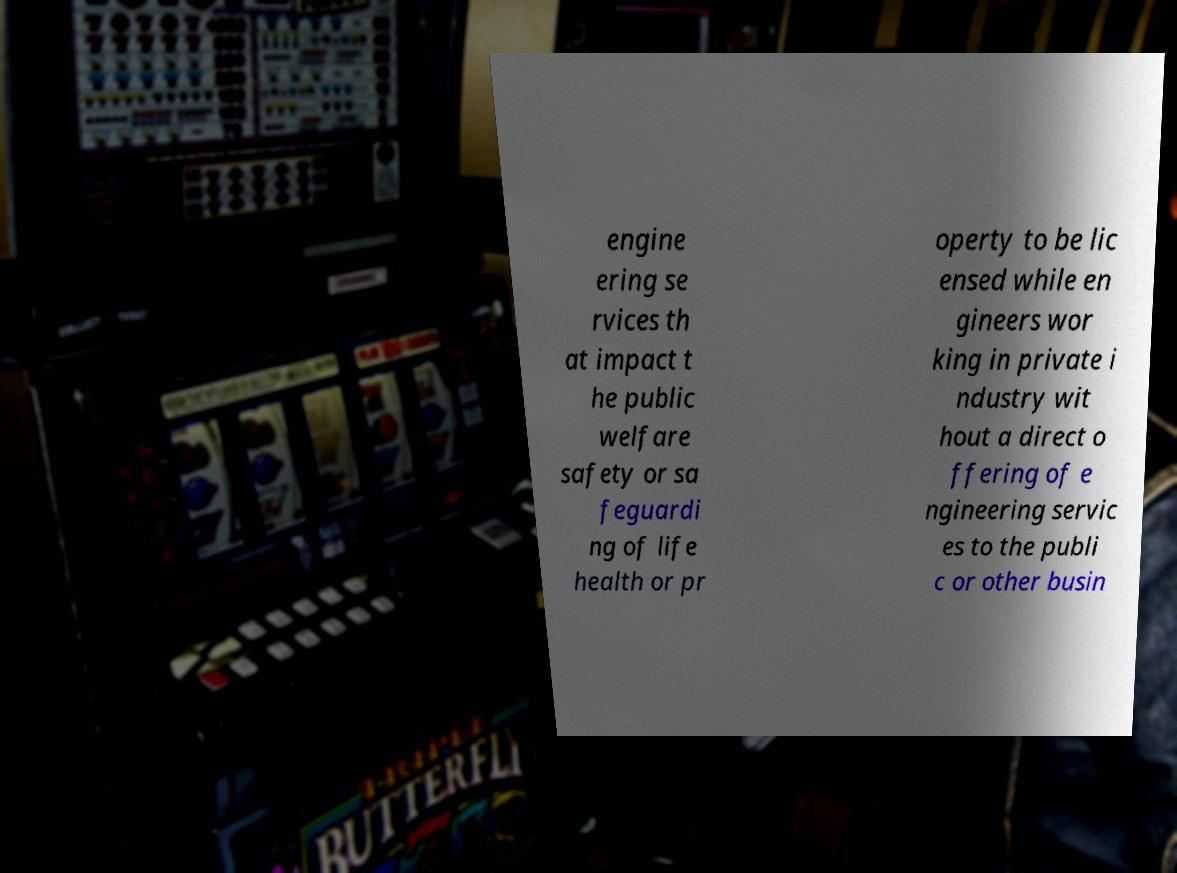Could you extract and type out the text from this image? engine ering se rvices th at impact t he public welfare safety or sa feguardi ng of life health or pr operty to be lic ensed while en gineers wor king in private i ndustry wit hout a direct o ffering of e ngineering servic es to the publi c or other busin 